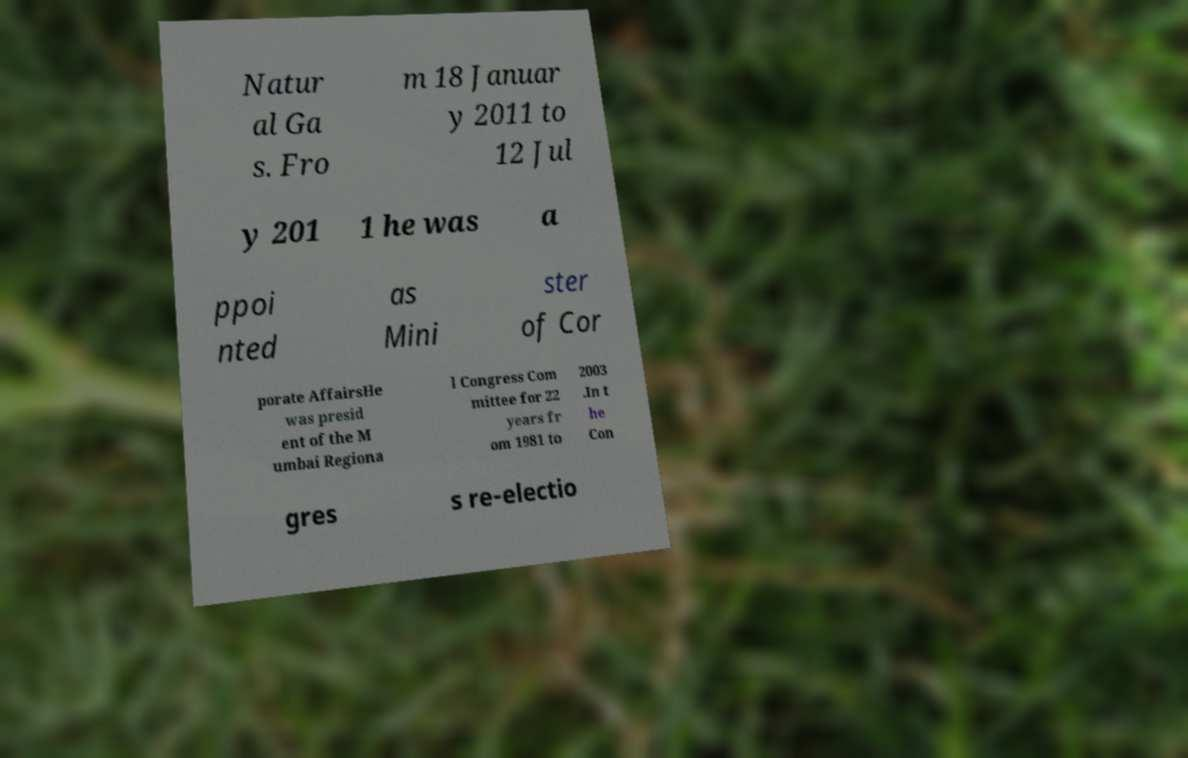Could you extract and type out the text from this image? Natur al Ga s. Fro m 18 Januar y 2011 to 12 Jul y 201 1 he was a ppoi nted as Mini ster of Cor porate AffairsHe was presid ent of the M umbai Regiona l Congress Com mittee for 22 years fr om 1981 to 2003 .In t he Con gres s re-electio 